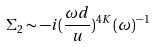Convert formula to latex. <formula><loc_0><loc_0><loc_500><loc_500>\Sigma _ { 2 } \sim - i ( \frac { \omega d } { u } ) ^ { 4 K } ( \omega ) ^ { - 1 }</formula> 